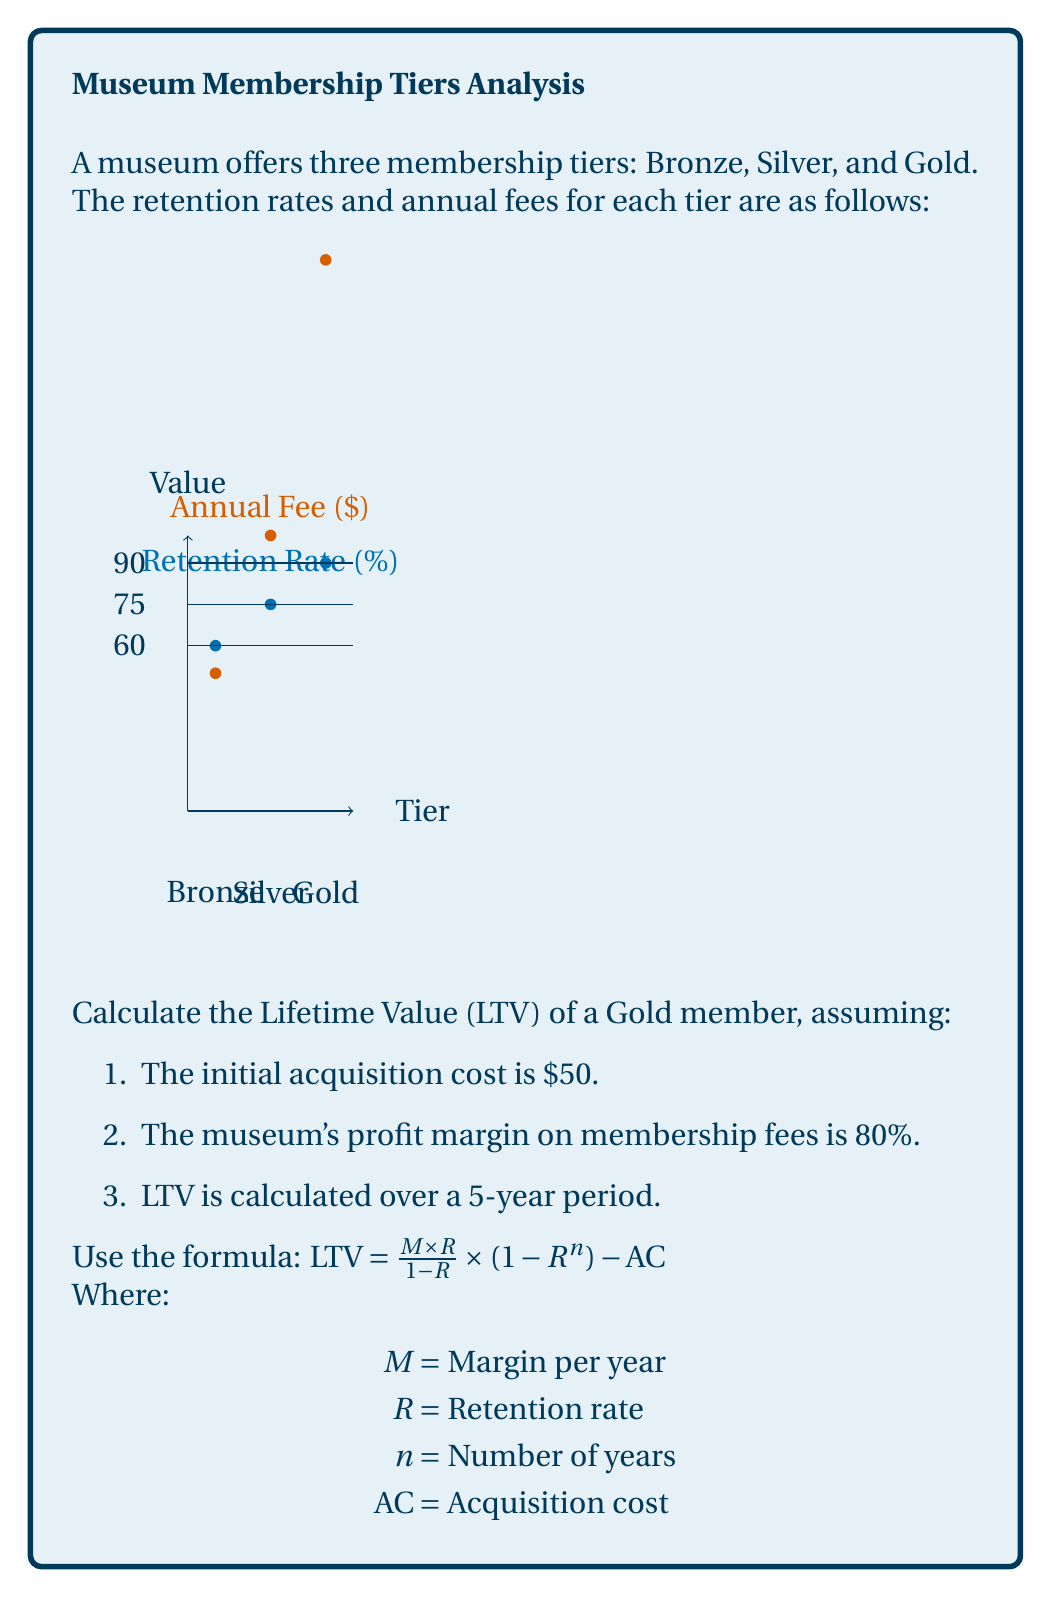Can you answer this question? Let's break this down step-by-step:

1) First, we need to identify the values for our formula:
   $M$ = Margin per year = Annual fee × Profit margin = $200 × 0.80 = $160
   $R$ = Retention rate = 90% = 0.90
   $n$ = Number of years = 5
   $AC$ = Acquisition cost = $50

2) Now, let's plug these values into our LTV formula:

   $LTV = \frac{M \times R}{1-R} \times (1 - R^n) - AC$

3) Substituting our values:

   $LTV = \frac{160 \times 0.90}{1-0.90} \times (1 - 0.90^5) - 50$

4) Let's calculate this step-by-step:
   
   a) $\frac{160 \times 0.90}{1-0.90} = \frac{144}{0.1} = 1440$
   
   b) $0.90^5 = 0.59049$
   
   c) $1 - 0.59049 = 0.40951$
   
   d) $1440 \times 0.40951 = 589.6944$
   
   e) $589.6944 - 50 = 539.6944$

5) Rounding to two decimal places:

   $LTV = $539.69$
Answer: $539.69 